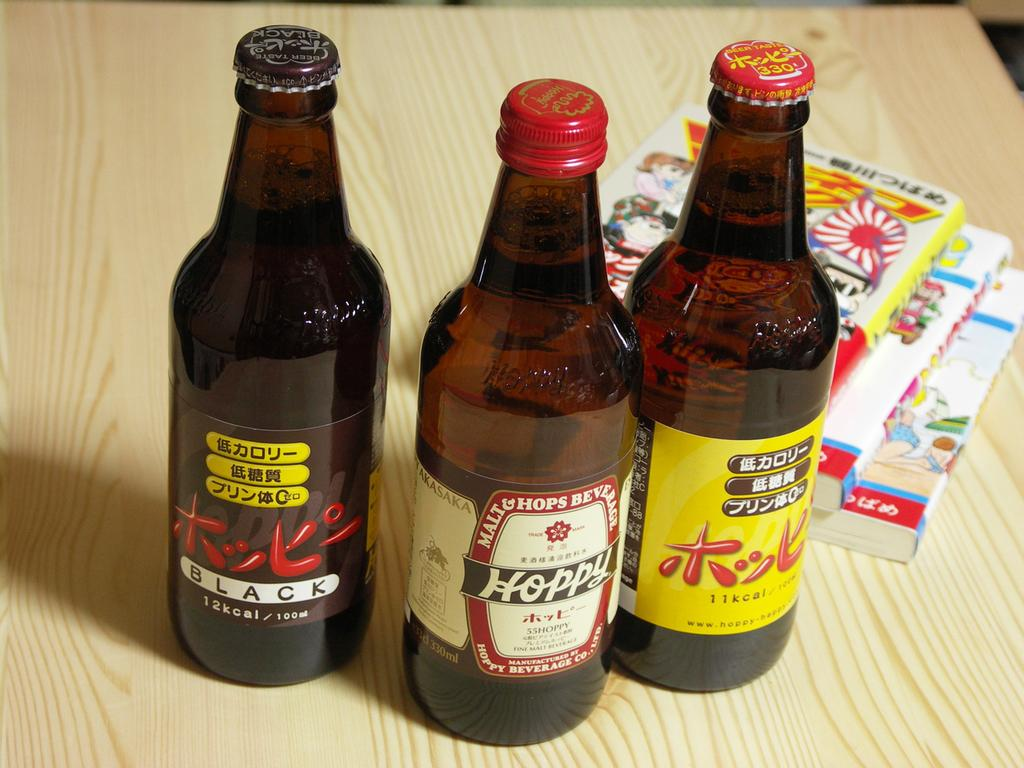What type of furniture is present in the image? There is a table in the image. What items are placed on the table? There are three wine bottles and three books on the table. Can you see the grandfather's smile in the image? There is no grandfather or smile present in the image. 